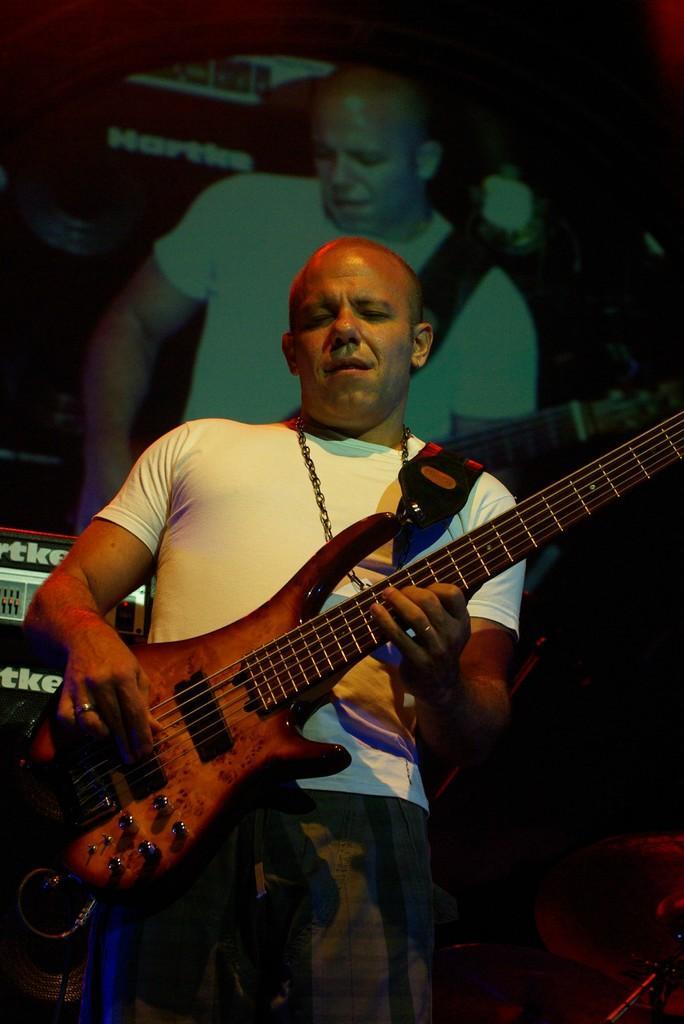Can you describe this image briefly? In this picture we can see man holding guitar in his hand and playing it and in background we can see a screen where same person is visible. 